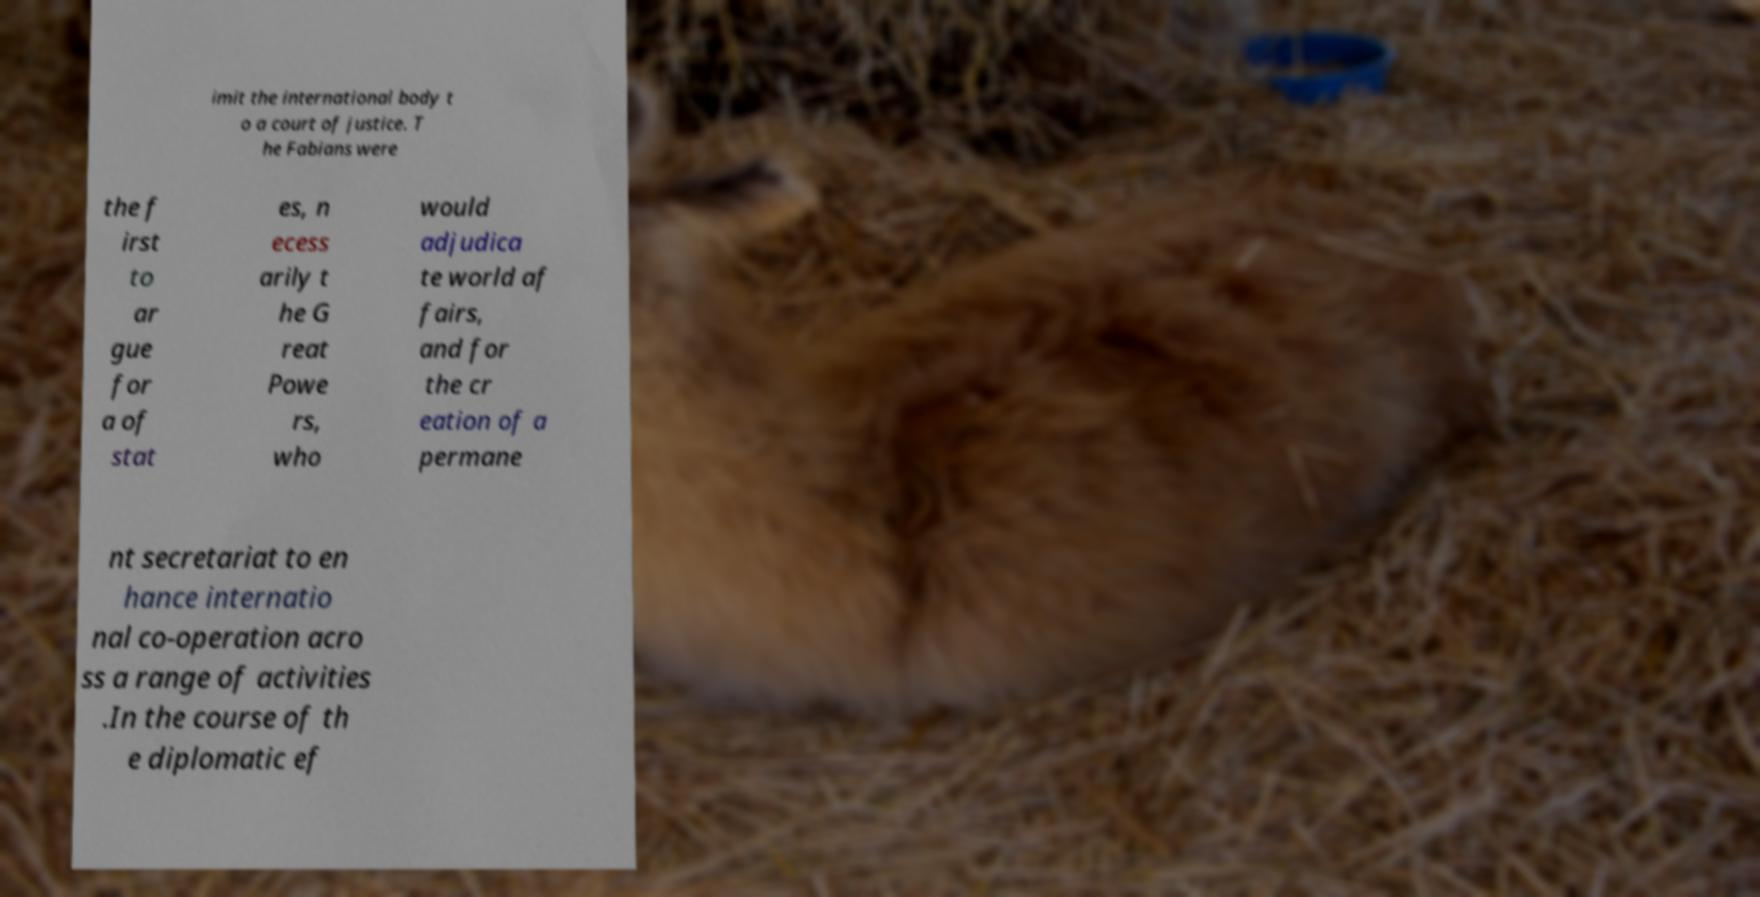Could you assist in decoding the text presented in this image and type it out clearly? imit the international body t o a court of justice. T he Fabians were the f irst to ar gue for a of stat es, n ecess arily t he G reat Powe rs, who would adjudica te world af fairs, and for the cr eation of a permane nt secretariat to en hance internatio nal co-operation acro ss a range of activities .In the course of th e diplomatic ef 